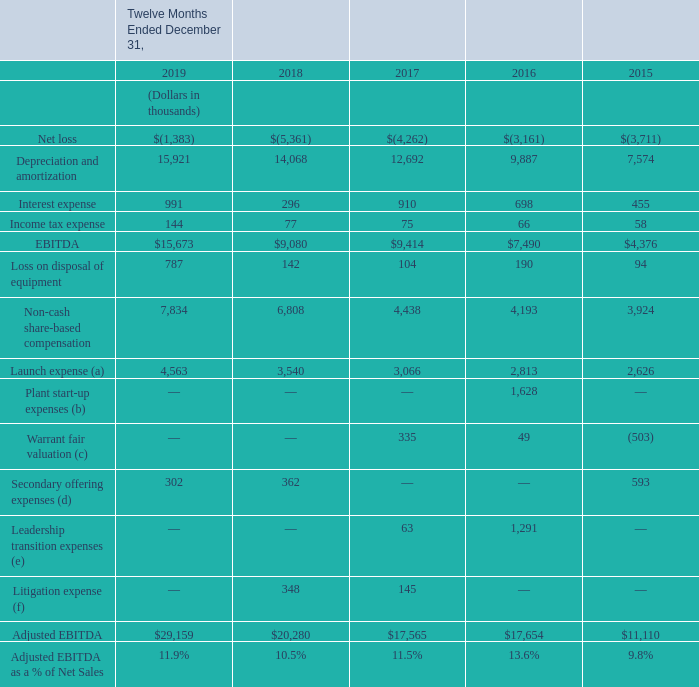The following table provides a reconciliation of EBITDA and Adjusted EBITDA to net loss, the most directly comparable financial measure presented in accordance with U.S. GAAP:
(a) Represents new store marketing allowance of $1,000 for each store added to our distribution network, as well as the non-capitalized freight costs associated with Freshpet Fridge replacements. The expense enhances the overall marketing spend to support our growing distribution network.
(b) Represents additional operating costs incurred in connection with the start-up of our new manufacturing lines as part of the Freshpet Kitchens expansion project in 2016 that included adding two additional product lines.
(c) Represents the change of fair value for the outstanding common stock warrants. All outstanding warrants were converted to common stock in September 2017.
(d) Represents fees associated with secondary public offerings of our common stock
(e) Represents charges associated with our former Chief Executive Officer’s separation agreement as well as changes in estimates associated with leadership transition costs.
(f) Represents fees associated with two securities lawsuits
What financial items does EBITDA consist of as shown in the table? Net loss, depreciation and amortization, interest expense, income tax expense. What is the Adjusted EBITDA for each of the financial year ends shown in the table (in chronological order) respectively?
Answer scale should be: thousand. $11,110, $17,654, $17,565, $20,280, $29,159. What was the EBITDA for each of the financial years ends listed shown in the table (in chronological order) respectively?
Answer scale should be: thousand. $4,376, $7,490, $9,414, $9,080, $15,673. What was the average EBITDA for 2018 and 2019?
Answer scale should be: thousand. (15,673+9,080)/2
Answer: 12376.5. What was the average adjusted EBITDA for 2018 and 2019?
Answer scale should be: thousand. (29,159+20,280)/2
Answer: 24719.5. What is the difference between average EBITDA and average adjusted EBITDA for 2018 and 2019?
Answer scale should be: thousand. [(29,159+20,280)/2] - [(15,673+9,080)/2]
Answer: 12343. 